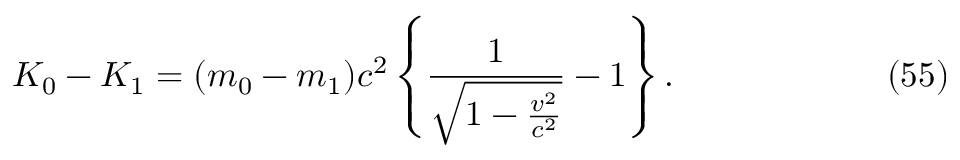<formula> <loc_0><loc_0><loc_500><loc_500>K _ { 0 } - K _ { 1 } = ( m _ { 0 } - m _ { 1 } ) c ^ { 2 } \left \{ \frac { 1 } { \sqrt { 1 - \frac { v ^ { 2 } } { c ^ { 2 } } } } - 1 \right \} . \ e q n o ( 5 5 )</formula> 